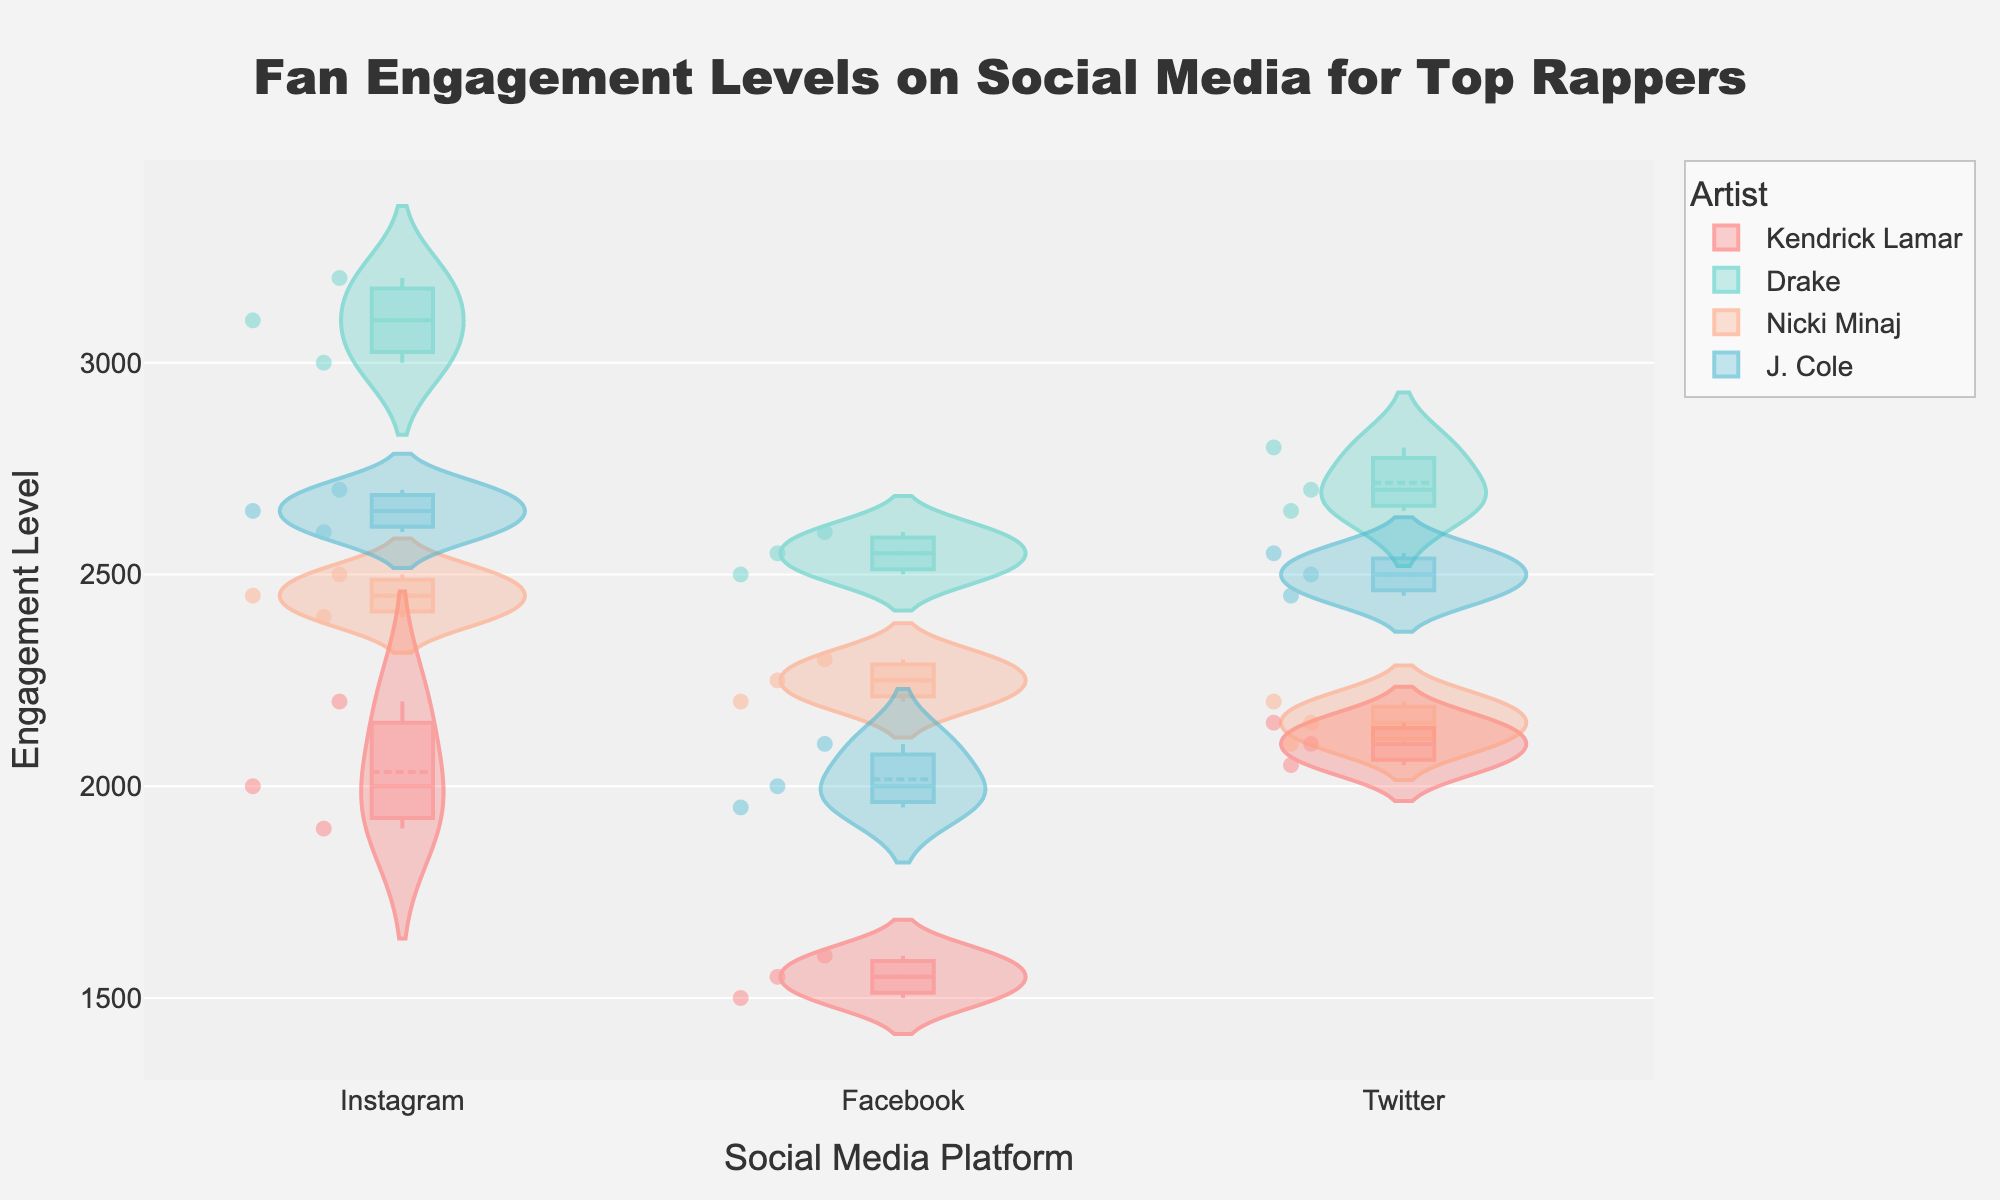Which artist has the highest median engagement on Instagram? By looking at the box plot overlay within the violin plot for each artist on Instagram, we can compare the median lines. Drake's median line is the highest among the artists.
Answer: Drake Which social media platform has the most consistent engagement levels for J. Cole? To determine consistency, we look at the width of the violin plots. The narrowest plot indicates less variability in engagement levels. For J. Cole, Instagram has the narrowest violin plot.
Answer: Instagram What is the range of engagement levels for Kendrick Lamar on Facebook? The range is determined by the difference between the maximum and minimum values shown in the violin and box plot. Kendrick Lamar's Facebook engagement ranges from 1500 to 1600.
Answer: 100 Which artist has the widest spread of engagement levels on Twitter? The widest spread is shown by the widest violin plot on Twitter. For Twitter, Nicki Minaj exhibits the widest spread in engagement levels.
Answer: Nicki Minaj How does Nicki Minaj's median engagement on Facebook compare to her median engagement on Instagram? We can compare the median lines in the box plots for Nicki Minaj on Facebook and Instagram. Her median engagement is higher on Instagram than on Facebook.
Answer: Higher on Instagram Which social media platform shows the highest engagement variability for Drake? Engagement variability is represented by the width of the violin plot. The widest violin plot for Drake is on Twitter, indicating the highest variability.
Answer: Twitter What is the difference between the maximum engagement levels of J. Cole on Facebook and Twitter? We look at the maximum points in the violin plots for J. Cole on both platforms. The maximum engagement on Facebook is 2100, and on Twitter is 2550. The difference is 2550 - 2100.
Answer: 450 Who has a higher median engagement on Twitter, Kendrick Lamar or Nicki Minaj? By comparing the median lines in the box plots for Kendrick Lamar and Nicki Minaj on Twitter, we see that Kendrick Lamar's median engagement is higher.
Answer: Kendrick Lamar Across all platforms, which artist generally has the highest engagement levels? Observing the upper ends of the violin plots for all platforms, Drake consistently has the highest engagement levels.
Answer: Drake Which artist has the least variability in engagement on any platform, and which platform is it? Least variability can be assessed by the narrowest violin plots. J. Cole on Instagram shows the least variability.
Answer: J. Cole on Instagram 